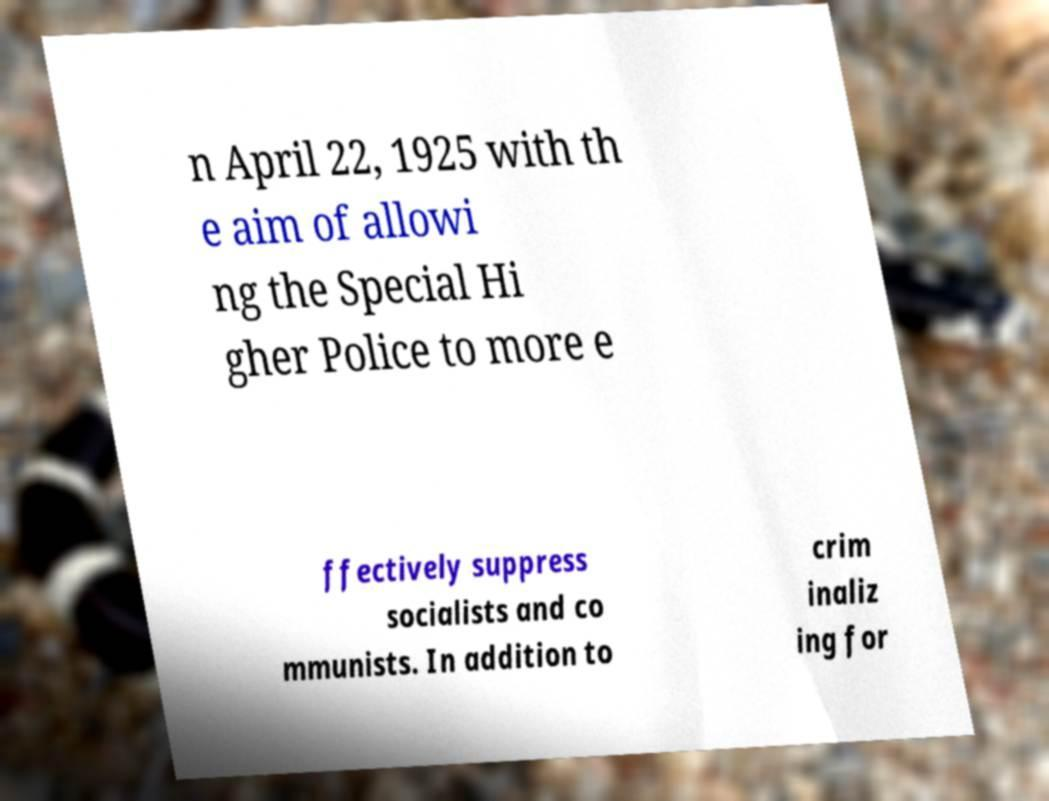There's text embedded in this image that I need extracted. Can you transcribe it verbatim? n April 22, 1925 with th e aim of allowi ng the Special Hi gher Police to more e ffectively suppress socialists and co mmunists. In addition to crim inaliz ing for 